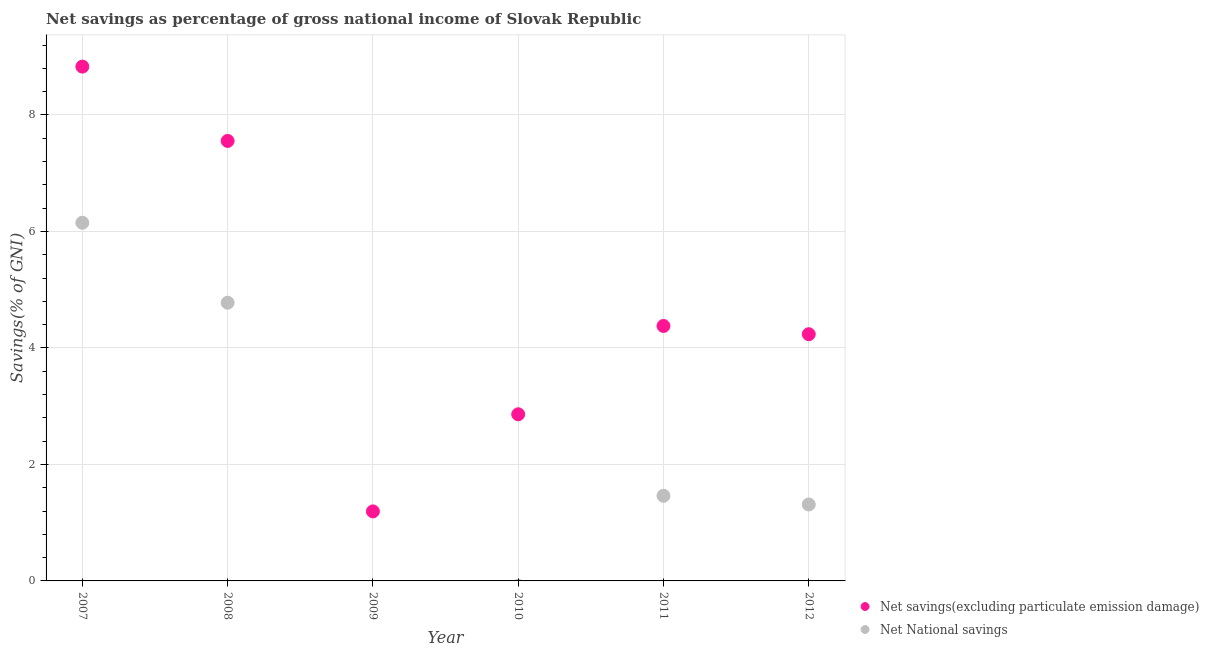How many different coloured dotlines are there?
Provide a succinct answer. 2. What is the net national savings in 2012?
Your answer should be compact. 1.31. Across all years, what is the maximum net national savings?
Provide a succinct answer. 6.15. Across all years, what is the minimum net savings(excluding particulate emission damage)?
Your answer should be very brief. 1.19. What is the total net savings(excluding particulate emission damage) in the graph?
Provide a succinct answer. 29.05. What is the difference between the net savings(excluding particulate emission damage) in 2008 and that in 2012?
Provide a succinct answer. 3.32. What is the difference between the net savings(excluding particulate emission damage) in 2010 and the net national savings in 2008?
Offer a very short reply. -1.92. What is the average net savings(excluding particulate emission damage) per year?
Your answer should be very brief. 4.84. In the year 2007, what is the difference between the net national savings and net savings(excluding particulate emission damage)?
Offer a very short reply. -2.68. What is the ratio of the net savings(excluding particulate emission damage) in 2008 to that in 2009?
Your response must be concise. 6.33. What is the difference between the highest and the second highest net national savings?
Offer a very short reply. 1.37. What is the difference between the highest and the lowest net savings(excluding particulate emission damage)?
Offer a very short reply. 7.64. In how many years, is the net savings(excluding particulate emission damage) greater than the average net savings(excluding particulate emission damage) taken over all years?
Provide a succinct answer. 2. Is the sum of the net national savings in 2011 and 2012 greater than the maximum net savings(excluding particulate emission damage) across all years?
Keep it short and to the point. No. Is the net savings(excluding particulate emission damage) strictly less than the net national savings over the years?
Ensure brevity in your answer.  No. How many dotlines are there?
Your response must be concise. 2. Are the values on the major ticks of Y-axis written in scientific E-notation?
Ensure brevity in your answer.  No. Does the graph contain grids?
Keep it short and to the point. Yes. Where does the legend appear in the graph?
Give a very brief answer. Bottom right. What is the title of the graph?
Your response must be concise. Net savings as percentage of gross national income of Slovak Republic. What is the label or title of the X-axis?
Your response must be concise. Year. What is the label or title of the Y-axis?
Provide a succinct answer. Savings(% of GNI). What is the Savings(% of GNI) in Net savings(excluding particulate emission damage) in 2007?
Your answer should be very brief. 8.83. What is the Savings(% of GNI) of Net National savings in 2007?
Keep it short and to the point. 6.15. What is the Savings(% of GNI) in Net savings(excluding particulate emission damage) in 2008?
Provide a short and direct response. 7.55. What is the Savings(% of GNI) in Net National savings in 2008?
Keep it short and to the point. 4.78. What is the Savings(% of GNI) in Net savings(excluding particulate emission damage) in 2009?
Make the answer very short. 1.19. What is the Savings(% of GNI) in Net National savings in 2009?
Provide a succinct answer. 0. What is the Savings(% of GNI) of Net savings(excluding particulate emission damage) in 2010?
Give a very brief answer. 2.86. What is the Savings(% of GNI) in Net savings(excluding particulate emission damage) in 2011?
Provide a succinct answer. 4.38. What is the Savings(% of GNI) of Net National savings in 2011?
Offer a very short reply. 1.46. What is the Savings(% of GNI) of Net savings(excluding particulate emission damage) in 2012?
Your response must be concise. 4.24. What is the Savings(% of GNI) of Net National savings in 2012?
Keep it short and to the point. 1.31. Across all years, what is the maximum Savings(% of GNI) of Net savings(excluding particulate emission damage)?
Your answer should be compact. 8.83. Across all years, what is the maximum Savings(% of GNI) in Net National savings?
Your answer should be compact. 6.15. Across all years, what is the minimum Savings(% of GNI) of Net savings(excluding particulate emission damage)?
Provide a succinct answer. 1.19. What is the total Savings(% of GNI) of Net savings(excluding particulate emission damage) in the graph?
Keep it short and to the point. 29.05. What is the total Savings(% of GNI) of Net National savings in the graph?
Your response must be concise. 13.7. What is the difference between the Savings(% of GNI) in Net savings(excluding particulate emission damage) in 2007 and that in 2008?
Provide a short and direct response. 1.28. What is the difference between the Savings(% of GNI) in Net National savings in 2007 and that in 2008?
Provide a short and direct response. 1.37. What is the difference between the Savings(% of GNI) of Net savings(excluding particulate emission damage) in 2007 and that in 2009?
Offer a very short reply. 7.64. What is the difference between the Savings(% of GNI) in Net savings(excluding particulate emission damage) in 2007 and that in 2010?
Your answer should be very brief. 5.97. What is the difference between the Savings(% of GNI) of Net savings(excluding particulate emission damage) in 2007 and that in 2011?
Keep it short and to the point. 4.45. What is the difference between the Savings(% of GNI) in Net National savings in 2007 and that in 2011?
Your response must be concise. 4.69. What is the difference between the Savings(% of GNI) of Net savings(excluding particulate emission damage) in 2007 and that in 2012?
Your response must be concise. 4.59. What is the difference between the Savings(% of GNI) of Net National savings in 2007 and that in 2012?
Keep it short and to the point. 4.84. What is the difference between the Savings(% of GNI) of Net savings(excluding particulate emission damage) in 2008 and that in 2009?
Keep it short and to the point. 6.36. What is the difference between the Savings(% of GNI) of Net savings(excluding particulate emission damage) in 2008 and that in 2010?
Give a very brief answer. 4.69. What is the difference between the Savings(% of GNI) of Net savings(excluding particulate emission damage) in 2008 and that in 2011?
Your response must be concise. 3.18. What is the difference between the Savings(% of GNI) of Net National savings in 2008 and that in 2011?
Your answer should be very brief. 3.32. What is the difference between the Savings(% of GNI) of Net savings(excluding particulate emission damage) in 2008 and that in 2012?
Offer a terse response. 3.32. What is the difference between the Savings(% of GNI) in Net National savings in 2008 and that in 2012?
Your response must be concise. 3.46. What is the difference between the Savings(% of GNI) of Net savings(excluding particulate emission damage) in 2009 and that in 2010?
Provide a short and direct response. -1.67. What is the difference between the Savings(% of GNI) of Net savings(excluding particulate emission damage) in 2009 and that in 2011?
Provide a succinct answer. -3.18. What is the difference between the Savings(% of GNI) in Net savings(excluding particulate emission damage) in 2009 and that in 2012?
Your answer should be very brief. -3.04. What is the difference between the Savings(% of GNI) of Net savings(excluding particulate emission damage) in 2010 and that in 2011?
Provide a succinct answer. -1.52. What is the difference between the Savings(% of GNI) of Net savings(excluding particulate emission damage) in 2010 and that in 2012?
Give a very brief answer. -1.37. What is the difference between the Savings(% of GNI) in Net savings(excluding particulate emission damage) in 2011 and that in 2012?
Your answer should be very brief. 0.14. What is the difference between the Savings(% of GNI) of Net National savings in 2011 and that in 2012?
Keep it short and to the point. 0.15. What is the difference between the Savings(% of GNI) in Net savings(excluding particulate emission damage) in 2007 and the Savings(% of GNI) in Net National savings in 2008?
Offer a very short reply. 4.05. What is the difference between the Savings(% of GNI) of Net savings(excluding particulate emission damage) in 2007 and the Savings(% of GNI) of Net National savings in 2011?
Your answer should be very brief. 7.37. What is the difference between the Savings(% of GNI) in Net savings(excluding particulate emission damage) in 2007 and the Savings(% of GNI) in Net National savings in 2012?
Keep it short and to the point. 7.52. What is the difference between the Savings(% of GNI) of Net savings(excluding particulate emission damage) in 2008 and the Savings(% of GNI) of Net National savings in 2011?
Provide a short and direct response. 6.09. What is the difference between the Savings(% of GNI) of Net savings(excluding particulate emission damage) in 2008 and the Savings(% of GNI) of Net National savings in 2012?
Give a very brief answer. 6.24. What is the difference between the Savings(% of GNI) in Net savings(excluding particulate emission damage) in 2009 and the Savings(% of GNI) in Net National savings in 2011?
Your response must be concise. -0.27. What is the difference between the Savings(% of GNI) in Net savings(excluding particulate emission damage) in 2009 and the Savings(% of GNI) in Net National savings in 2012?
Your answer should be compact. -0.12. What is the difference between the Savings(% of GNI) in Net savings(excluding particulate emission damage) in 2010 and the Savings(% of GNI) in Net National savings in 2011?
Provide a short and direct response. 1.4. What is the difference between the Savings(% of GNI) of Net savings(excluding particulate emission damage) in 2010 and the Savings(% of GNI) of Net National savings in 2012?
Offer a very short reply. 1.55. What is the difference between the Savings(% of GNI) of Net savings(excluding particulate emission damage) in 2011 and the Savings(% of GNI) of Net National savings in 2012?
Provide a succinct answer. 3.07. What is the average Savings(% of GNI) of Net savings(excluding particulate emission damage) per year?
Provide a short and direct response. 4.84. What is the average Savings(% of GNI) in Net National savings per year?
Your response must be concise. 2.28. In the year 2007, what is the difference between the Savings(% of GNI) in Net savings(excluding particulate emission damage) and Savings(% of GNI) in Net National savings?
Provide a short and direct response. 2.68. In the year 2008, what is the difference between the Savings(% of GNI) in Net savings(excluding particulate emission damage) and Savings(% of GNI) in Net National savings?
Your response must be concise. 2.78. In the year 2011, what is the difference between the Savings(% of GNI) in Net savings(excluding particulate emission damage) and Savings(% of GNI) in Net National savings?
Offer a terse response. 2.92. In the year 2012, what is the difference between the Savings(% of GNI) of Net savings(excluding particulate emission damage) and Savings(% of GNI) of Net National savings?
Offer a very short reply. 2.92. What is the ratio of the Savings(% of GNI) in Net savings(excluding particulate emission damage) in 2007 to that in 2008?
Give a very brief answer. 1.17. What is the ratio of the Savings(% of GNI) in Net National savings in 2007 to that in 2008?
Keep it short and to the point. 1.29. What is the ratio of the Savings(% of GNI) in Net savings(excluding particulate emission damage) in 2007 to that in 2009?
Keep it short and to the point. 7.4. What is the ratio of the Savings(% of GNI) of Net savings(excluding particulate emission damage) in 2007 to that in 2010?
Give a very brief answer. 3.09. What is the ratio of the Savings(% of GNI) in Net savings(excluding particulate emission damage) in 2007 to that in 2011?
Keep it short and to the point. 2.02. What is the ratio of the Savings(% of GNI) in Net National savings in 2007 to that in 2011?
Make the answer very short. 4.21. What is the ratio of the Savings(% of GNI) of Net savings(excluding particulate emission damage) in 2007 to that in 2012?
Offer a terse response. 2.08. What is the ratio of the Savings(% of GNI) in Net National savings in 2007 to that in 2012?
Make the answer very short. 4.69. What is the ratio of the Savings(% of GNI) of Net savings(excluding particulate emission damage) in 2008 to that in 2009?
Keep it short and to the point. 6.33. What is the ratio of the Savings(% of GNI) in Net savings(excluding particulate emission damage) in 2008 to that in 2010?
Your response must be concise. 2.64. What is the ratio of the Savings(% of GNI) in Net savings(excluding particulate emission damage) in 2008 to that in 2011?
Provide a short and direct response. 1.73. What is the ratio of the Savings(% of GNI) of Net National savings in 2008 to that in 2011?
Keep it short and to the point. 3.27. What is the ratio of the Savings(% of GNI) in Net savings(excluding particulate emission damage) in 2008 to that in 2012?
Offer a very short reply. 1.78. What is the ratio of the Savings(% of GNI) of Net National savings in 2008 to that in 2012?
Make the answer very short. 3.64. What is the ratio of the Savings(% of GNI) of Net savings(excluding particulate emission damage) in 2009 to that in 2010?
Your response must be concise. 0.42. What is the ratio of the Savings(% of GNI) in Net savings(excluding particulate emission damage) in 2009 to that in 2011?
Provide a short and direct response. 0.27. What is the ratio of the Savings(% of GNI) in Net savings(excluding particulate emission damage) in 2009 to that in 2012?
Offer a very short reply. 0.28. What is the ratio of the Savings(% of GNI) in Net savings(excluding particulate emission damage) in 2010 to that in 2011?
Offer a very short reply. 0.65. What is the ratio of the Savings(% of GNI) of Net savings(excluding particulate emission damage) in 2010 to that in 2012?
Give a very brief answer. 0.68. What is the ratio of the Savings(% of GNI) in Net savings(excluding particulate emission damage) in 2011 to that in 2012?
Make the answer very short. 1.03. What is the ratio of the Savings(% of GNI) of Net National savings in 2011 to that in 2012?
Offer a very short reply. 1.11. What is the difference between the highest and the second highest Savings(% of GNI) of Net savings(excluding particulate emission damage)?
Keep it short and to the point. 1.28. What is the difference between the highest and the second highest Savings(% of GNI) in Net National savings?
Provide a short and direct response. 1.37. What is the difference between the highest and the lowest Savings(% of GNI) of Net savings(excluding particulate emission damage)?
Offer a very short reply. 7.64. What is the difference between the highest and the lowest Savings(% of GNI) in Net National savings?
Your answer should be compact. 6.15. 